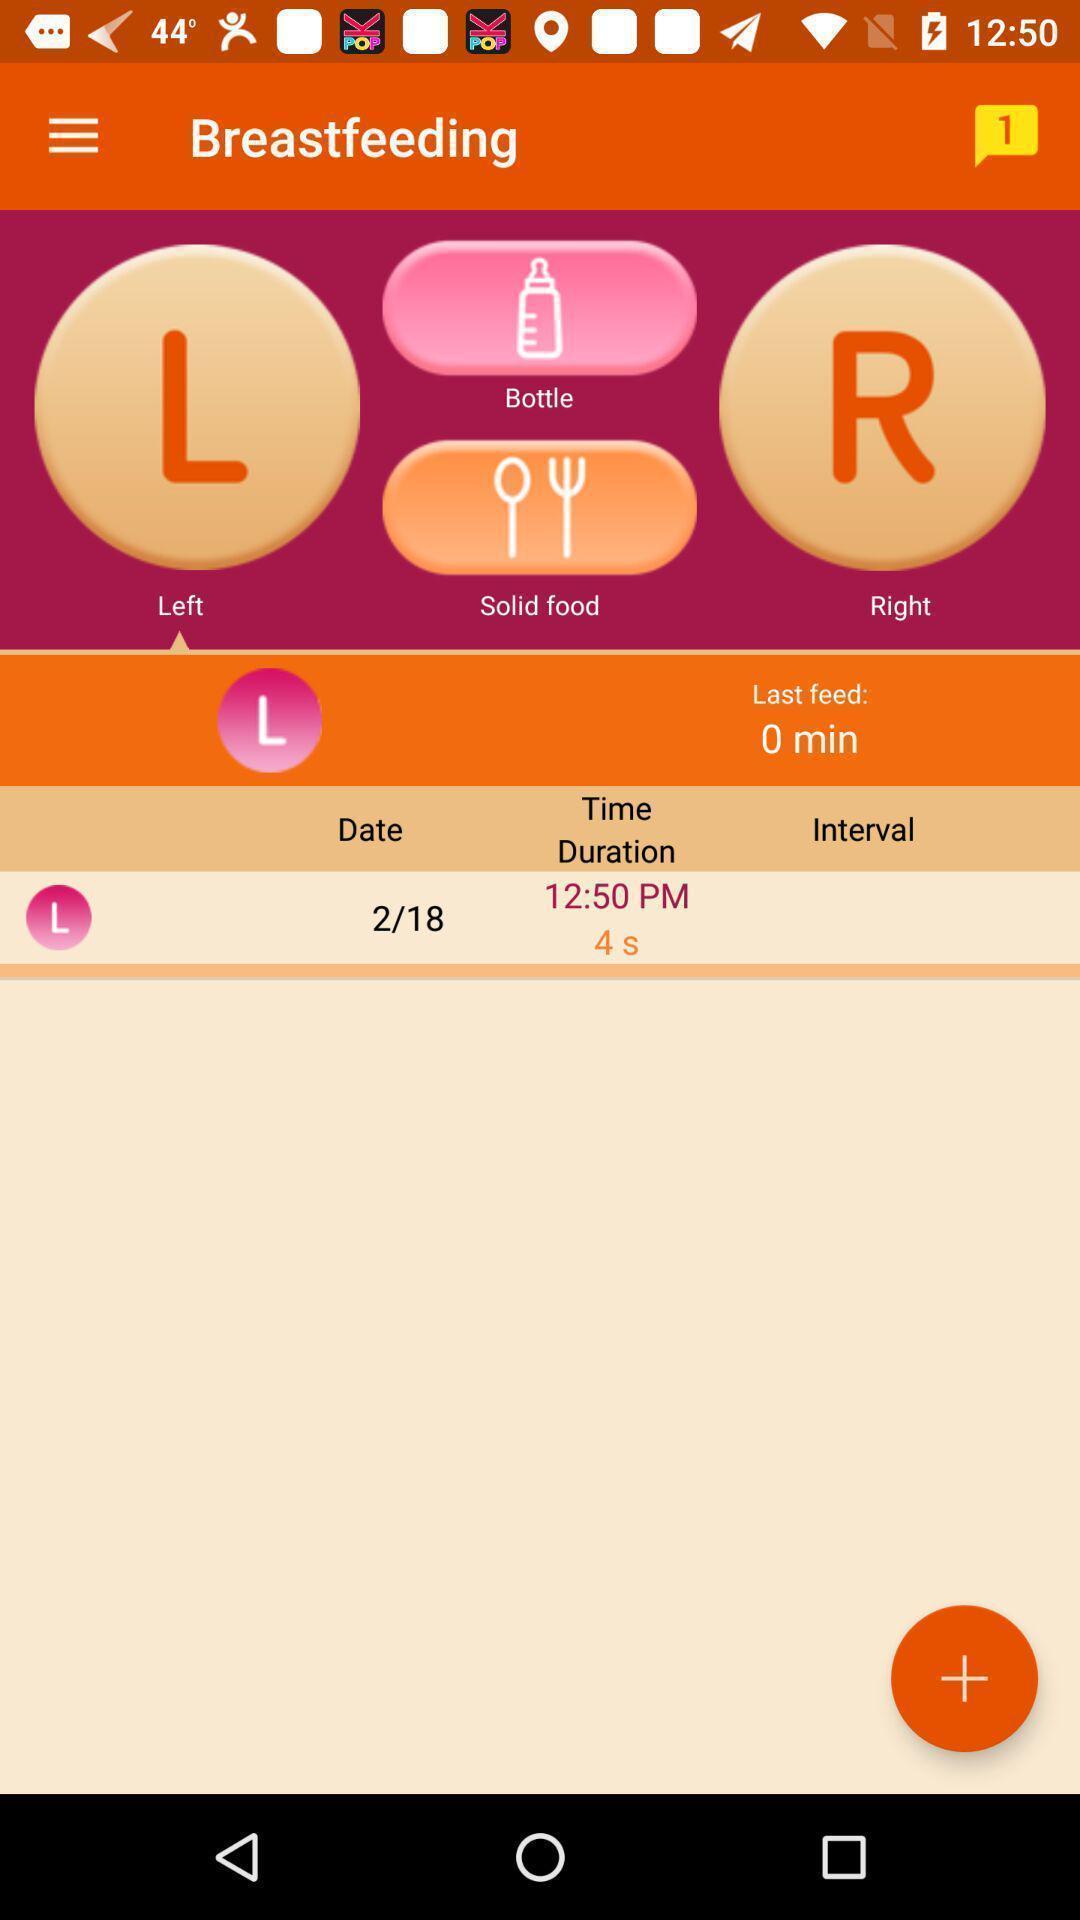Describe this image in words. Starting page. 